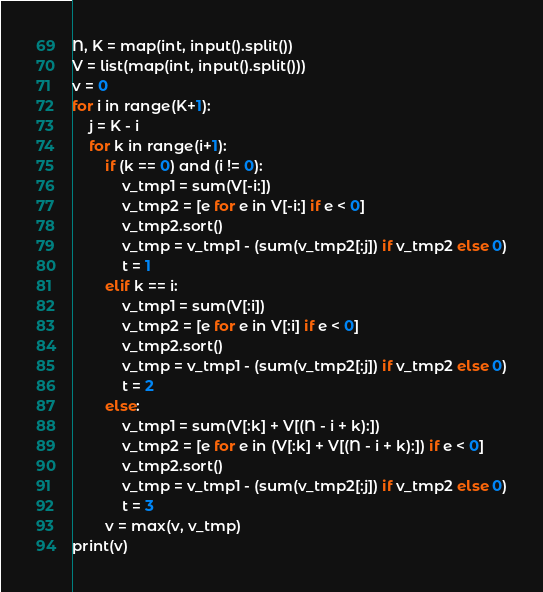Convert code to text. <code><loc_0><loc_0><loc_500><loc_500><_Python_>N, K = map(int, input().split())
V = list(map(int, input().split()))
v = 0
for i in range(K+1):
    j = K - i
    for k in range(i+1):
        if (k == 0) and (i != 0):
            v_tmp1 = sum(V[-i:])
            v_tmp2 = [e for e in V[-i:] if e < 0]
            v_tmp2.sort()
            v_tmp = v_tmp1 - (sum(v_tmp2[:j]) if v_tmp2 else 0)
            t = 1
        elif k == i:
            v_tmp1 = sum(V[:i])
            v_tmp2 = [e for e in V[:i] if e < 0]
            v_tmp2.sort()
            v_tmp = v_tmp1 - (sum(v_tmp2[:j]) if v_tmp2 else 0)
            t = 2
        else:
            v_tmp1 = sum(V[:k] + V[(N - i + k):])
            v_tmp2 = [e for e in (V[:k] + V[(N - i + k):]) if e < 0]
            v_tmp2.sort()
            v_tmp = v_tmp1 - (sum(v_tmp2[:j]) if v_tmp2 else 0)
            t = 3
        v = max(v, v_tmp)
print(v)</code> 